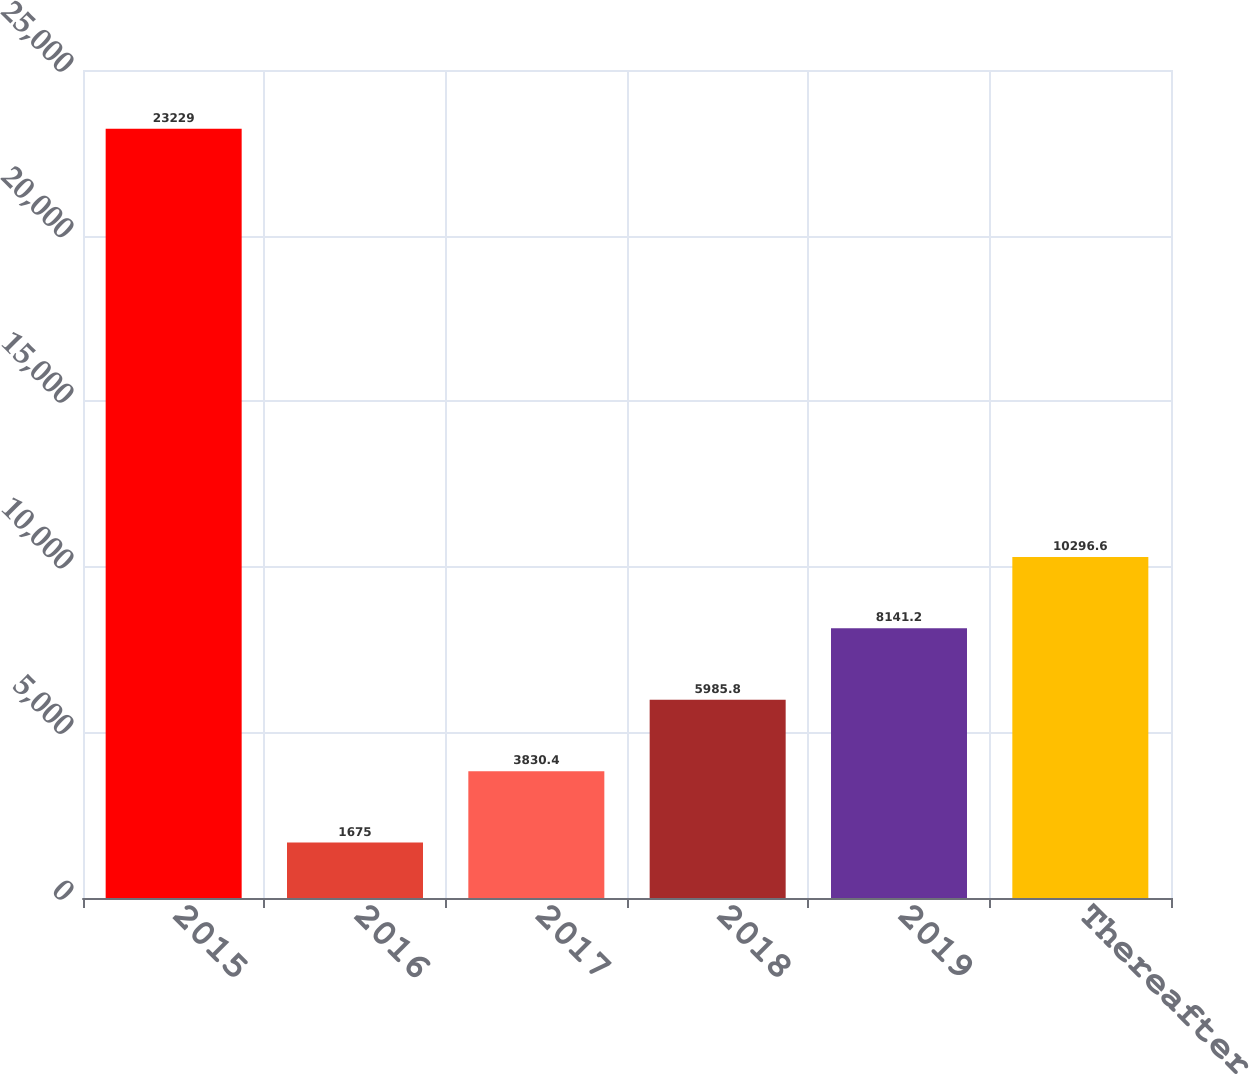Convert chart to OTSL. <chart><loc_0><loc_0><loc_500><loc_500><bar_chart><fcel>2015<fcel>2016<fcel>2017<fcel>2018<fcel>2019<fcel>Thereafter<nl><fcel>23229<fcel>1675<fcel>3830.4<fcel>5985.8<fcel>8141.2<fcel>10296.6<nl></chart> 